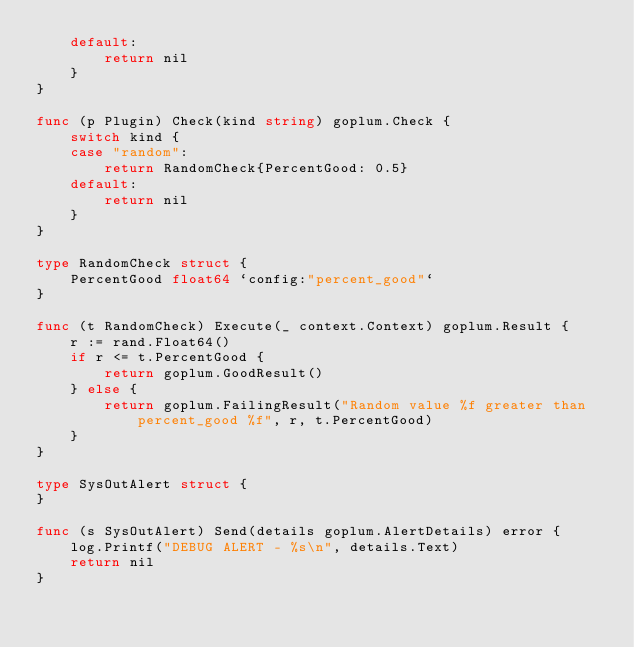Convert code to text. <code><loc_0><loc_0><loc_500><loc_500><_Go_>	default:
		return nil
	}
}

func (p Plugin) Check(kind string) goplum.Check {
	switch kind {
	case "random":
		return RandomCheck{PercentGood: 0.5}
	default:
		return nil
	}
}

type RandomCheck struct {
	PercentGood float64 `config:"percent_good"`
}

func (t RandomCheck) Execute(_ context.Context) goplum.Result {
	r := rand.Float64()
	if r <= t.PercentGood {
		return goplum.GoodResult()
	} else {
		return goplum.FailingResult("Random value %f greater than percent_good %f", r, t.PercentGood)
	}
}

type SysOutAlert struct {
}

func (s SysOutAlert) Send(details goplum.AlertDetails) error {
	log.Printf("DEBUG ALERT - %s\n", details.Text)
	return nil
}
</code> 